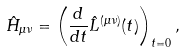<formula> <loc_0><loc_0><loc_500><loc_500>\hat { H } _ { \mu \nu } = \left ( \frac { d } { d t } \hat { L } ^ { ( \mu \nu ) } ( t ) \right ) _ { t = 0 } ,</formula> 